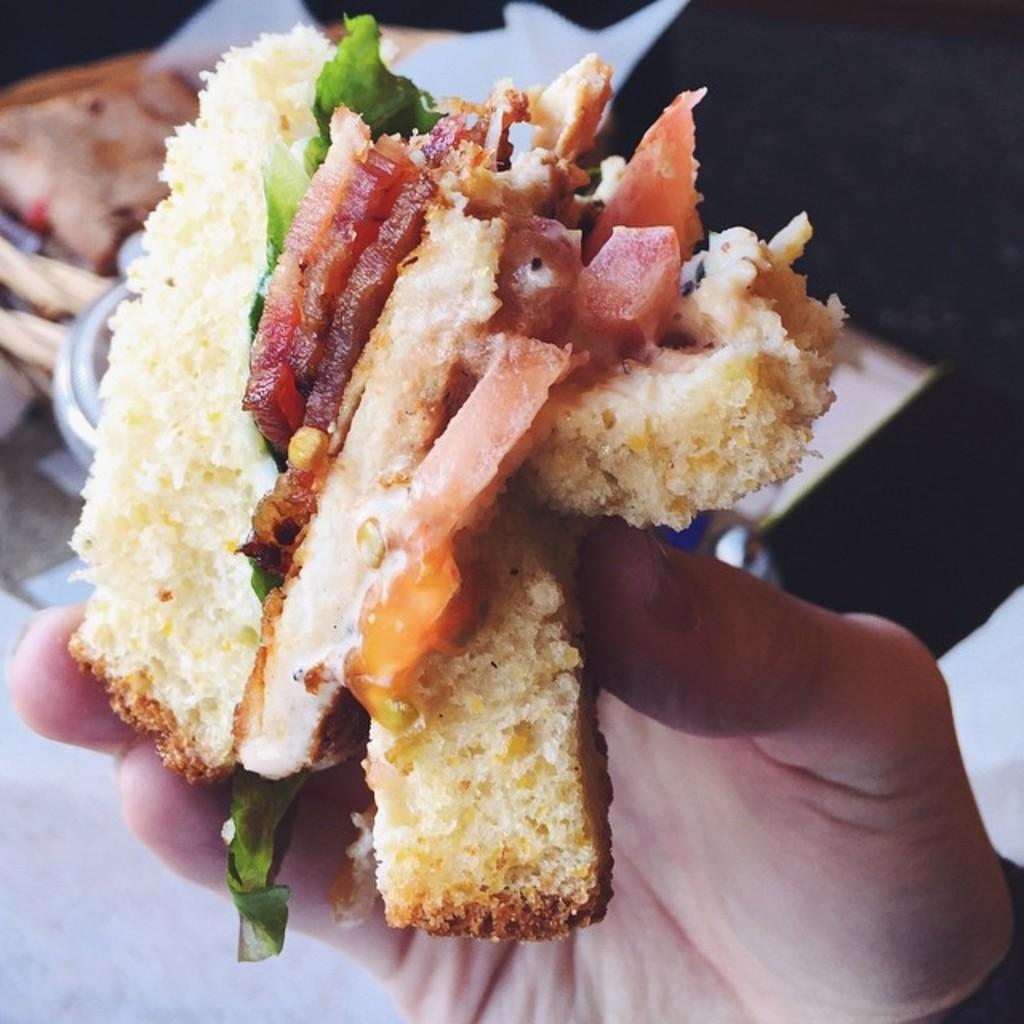Describe this image in one or two sentences. In the center of the image we can see food in person's hand. In the background we can see food and bowl placed on the table. 